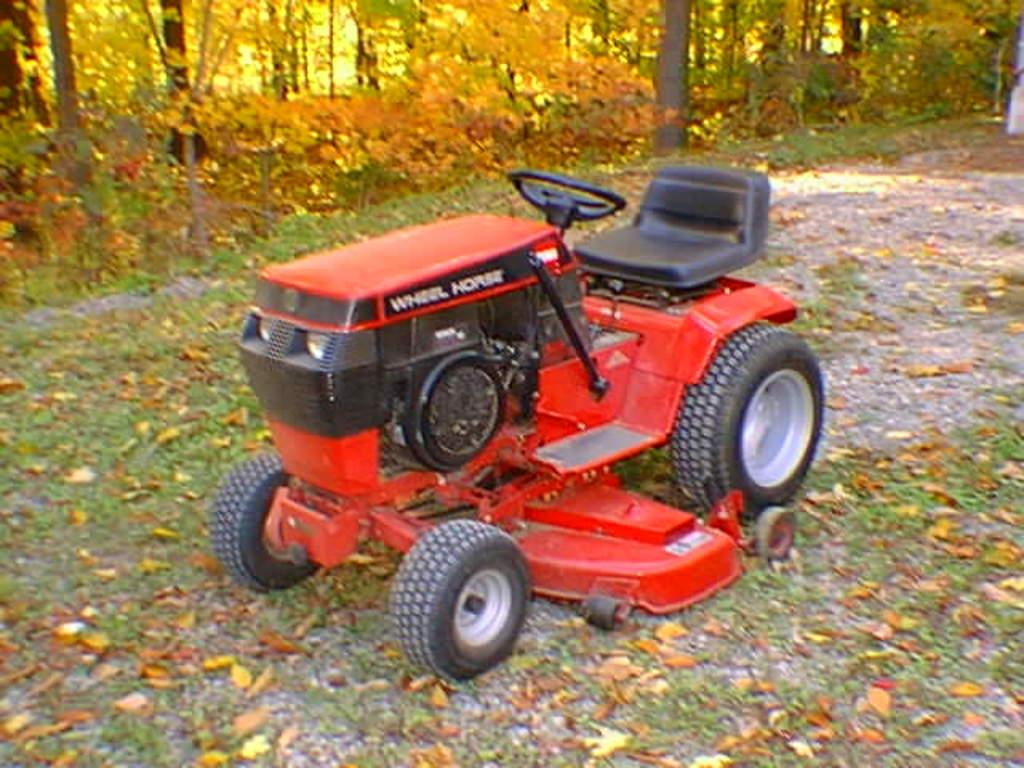What is the main subject in the center of the image? There is a vehicle in the center of the image. What can be seen in the background of the image? There are trees in the background of the image. What type of vegetation is visible at the bottom of the image? Leaves are visible at the bottom of the image. What type of sail can be seen on the vehicle in the image? There is no sail present on the vehicle in the image. 